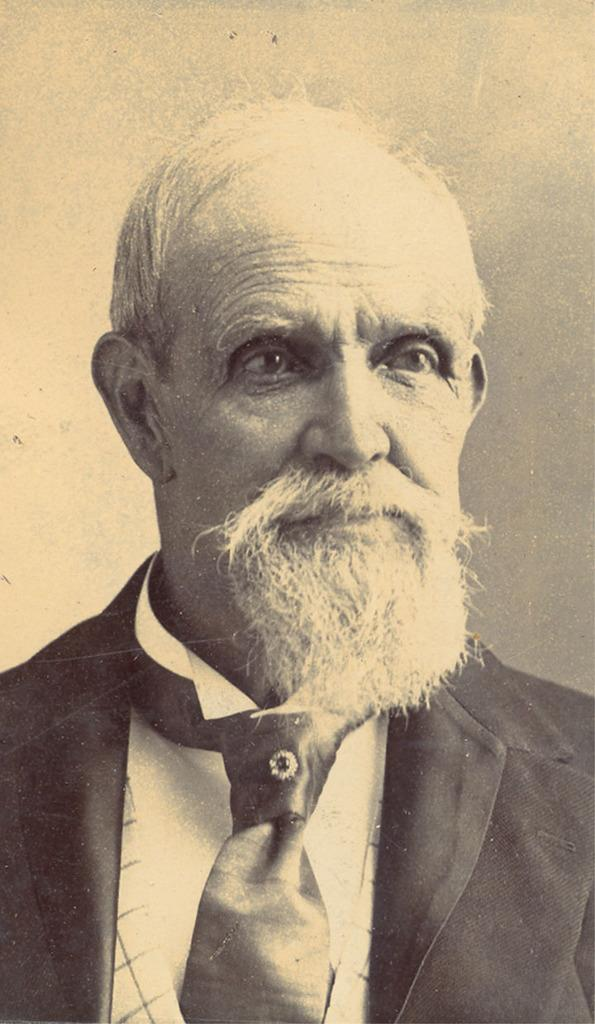Who or what is the main subject of the image? There is a person in the image. What type of clothing is the person wearing? The person is wearing a blazer and a tie. What is the color scheme of the image? The image is in black and white. What type of animal can be seen drinking milk in the image? There is no animal or milk present in the image; it features a person wearing a blazer and a tie in black and white. How many pizzas are visible on the person's plate in the image? There are no pizzas present in the image. 